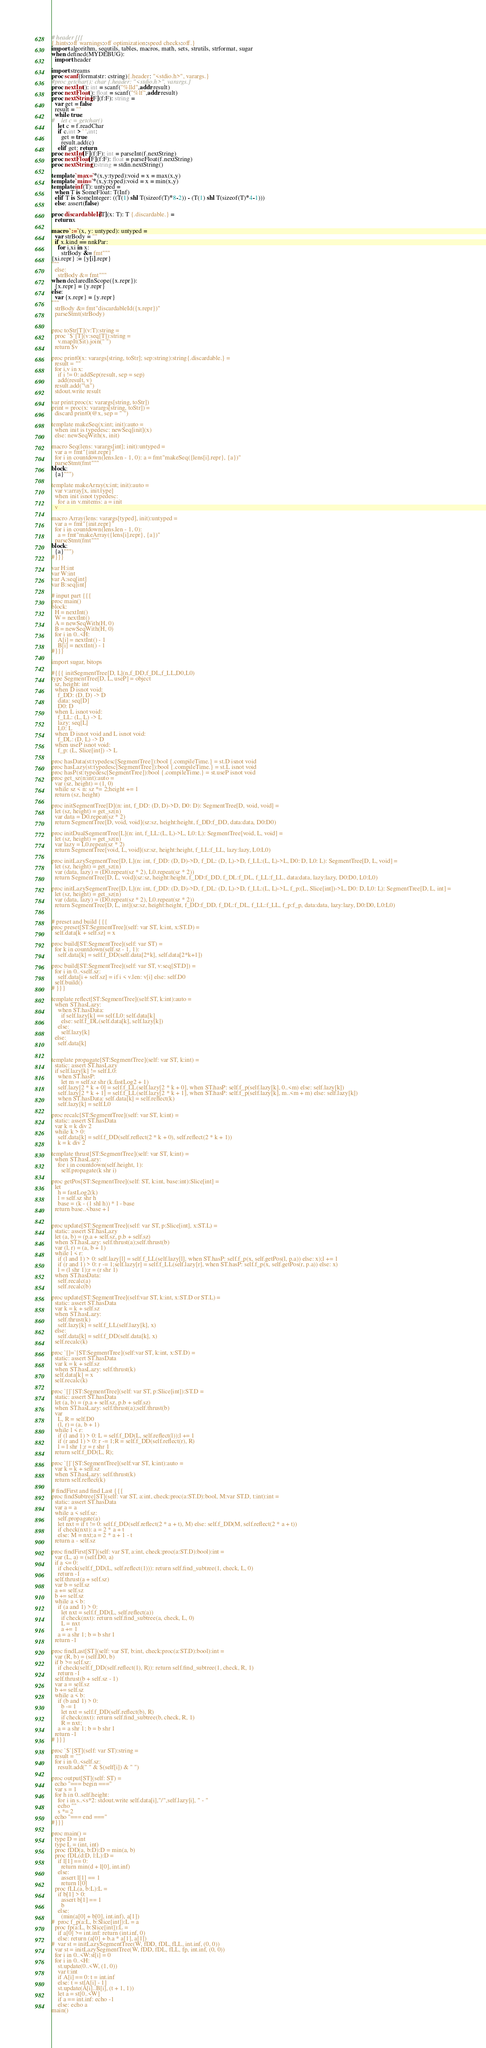<code> <loc_0><loc_0><loc_500><loc_500><_Nim_># header {{{
{.hints:off warnings:off optimization:speed checks:off.}
import algorithm, sequtils, tables, macros, math, sets, strutils, strformat, sugar
when defined(MYDEBUG):
  import header

import streams
proc scanf(formatstr: cstring){.header: "<stdio.h>", varargs.}
#proc getchar(): char {.header: "<stdio.h>", varargs.}
proc nextInt(): int = scanf("%lld",addr result)
proc nextFloat(): float = scanf("%lf",addr result)
proc nextString[F](f:F): string =
  var get = false
  result = ""
  while true:
#    let c = getchar()
    let c = f.readChar
    if c.int > ' '.int:
      get = true
      result.add(c)
    elif get: return
proc nextInt[F](f:F): int = parseInt(f.nextString)
proc nextFloat[F](f:F): float = parseFloat(f.nextString)
proc nextString():string = stdin.nextString()

template `max=`*(x,y:typed):void = x = max(x,y)
template `min=`*(x,y:typed):void = x = min(x,y)
template inf(T): untyped = 
  when T is SomeFloat: T(Inf)
  elif T is SomeInteger: ((T(1) shl T(sizeof(T)*8-2)) - (T(1) shl T(sizeof(T)*4-1)))
  else: assert(false)

proc discardableId[T](x: T): T {.discardable.} =
  return x

macro `:=`(x, y: untyped): untyped =
  var strBody = ""
  if x.kind == nnkPar:
    for i,xi in x:
      strBody &= fmt"""
{xi.repr} := {y[i].repr}
"""
  else:
    strBody &= fmt"""
when declaredInScope({x.repr}):
  {x.repr} = {y.repr}
else:
  var {x.repr} = {y.repr}
"""
  strBody &= fmt"discardableId({x.repr})"
  parseStmt(strBody)


proc toStr[T](v:T):string =
  proc `$`[T](v:seq[T]):string =
    v.mapIt($it).join(" ")
  return $v

proc print0(x: varargs[string, toStr]; sep:string):string{.discardable.} =
  result = ""
  for i,v in x:
    if i != 0: addSep(result, sep = sep)
    add(result, v)
  result.add("\n")
  stdout.write result

var print:proc(x: varargs[string, toStr])
print = proc(x: varargs[string, toStr]) =
  discard print0(@x, sep = " ")

template makeSeq(x:int; init):auto =
  when init is typedesc: newSeq[init](x)
  else: newSeqWith(x, init)

macro Seq(lens: varargs[int]; init):untyped =
  var a = fmt"{init.repr}"
  for i in countdown(lens.len - 1, 0): a = fmt"makeSeq({lens[i].repr}, {a})"
  parseStmt(fmt"""
block:
  {a}""")

template makeArray(x:int; init):auto =
  var v:array[x, init.type]
  when init isnot typedesc:
    for a in v.mitems: a = init
  v

macro Array(lens: varargs[typed], init):untyped =
  var a = fmt"{init.repr}"
  for i in countdown(lens.len - 1, 0):
    a = fmt"makeArray({lens[i].repr}, {a})"
  parseStmt(fmt"""
block:
  {a}""")
#}}}

var H:int
var W:int
var A:seq[int]
var B:seq[int]

# input part {{{
proc main()
block:
  H = nextInt()
  W = nextInt()
  A = newSeqWith(H, 0)
  B = newSeqWith(H, 0)
  for i in 0..<H:
    A[i] = nextInt() - 1
    B[i] = nextInt() - 1
#}}}

import sugar, bitops

#{{{ initSegmentTree[D, L](n,f_DD,f_DL,f_LL,D0,L0)
type SegmentTree[D, L, useP] = object
  sz, height: int
  when D isnot void:
    f_DD: (D, D) -> D
    data: seq[D]
    D0: D
  when L isnot void:
    f_LL: (L, L) -> L
    lazy: seq[L]
    L0: L
  when D isnot void and L isnot void:
    f_DL: (D, L) -> D
  when useP isnot void:
    f_p: (L, Slice[int]) -> L

proc hasData(st:typedesc[SegmentTree]):bool {.compileTime.} = st.D isnot void
proc hasLazy(st:typedesc[SegmentTree]):bool {.compileTime.} = st.L isnot void
proc hasP(st:typedesc[SegmentTree]):bool {.compileTime.} = st.useP isnot void
proc get_sz(n:int):auto =
  var (sz, height) = (1, 0)
  while sz < n: sz *= 2;height += 1
  return (sz, height)

proc initSegmentTree[D](n: int, f_DD: (D, D)->D, D0: D): SegmentTree[D, void, void] =
  let (sz, height) = get_sz(n)
  var data = D0.repeat(sz * 2)
  return SegmentTree[D, void, void](sz:sz, height:height, f_DD:f_DD, data:data, D0:D0)

proc initDualSegmentTree[L](n: int, f_LL:(L, L)->L, L0: L): SegmentTree[void, L, void] =
  let (sz, height) = get_sz(n)
  var lazy = L0.repeat(sz * 2)
  return SegmentTree[void, L, void](sz:sz, height:height, f_LL:f_LL, lazy:lazy, L0:L0)

proc initLazySegmentTree[D, L](n: int, f_DD: (D, D)->D, f_DL: (D, L)->D, f_LL:(L, L)->L, D0: D, L0: L): SegmentTree[D, L, void] =
  let (sz, height) = get_sz(n)
  var (data, lazy) = (D0.repeat(sz * 2), L0.repeat(sz * 2))
  return SegmentTree[D, L, void](sz:sz, height:height, f_DD:f_DD, f_DL:f_DL, f_LL:f_LL, data:data, lazy:lazy, D0:D0, L0:L0)

proc initLazySegmentTree[D, L](n: int, f_DD: (D, D)->D, f_DL: (D, L)->D, f_LL:(L, L)->L, f_p:(L, Slice[int])->L, D0: D, L0: L): SegmentTree[D, L, int] =
  let (sz, height) = get_sz(n)
  var (data, lazy) = (D0.repeat(sz * 2), L0.repeat(sz * 2))
  return SegmentTree[D, L, int](sz:sz, height:height, f_DD:f_DD, f_DL:f_DL, f_LL:f_LL, f_p:f_p, data:data, lazy:lazy, D0:D0, L0:L0)


# preset and build {{{
proc preset[ST:SegmentTree](self: var ST, k:int, x:ST.D) =
  self.data[k + self.sz] = x

proc build[ST:SegmentTree](self: var ST) =
  for k in countdown(self.sz - 1, 1):
    self.data[k] = self.f_DD(self.data[2*k], self.data[2*k+1])

proc build[ST:SegmentTree](self: var ST, v:seq[ST.D]) =
  for i in 0..<self.sz:
    self.data[i + self.sz] = if i < v.len: v[i] else: self.D0
  self.build()
# }}}

template reflect[ST:SegmentTree](self:ST, k:int):auto =
  when ST.hasLazy:
    when ST.hasData:
      if self.lazy[k] == self.L0: self.data[k]
      else: self.f_DL(self.data[k], self.lazy[k])
    else:
      self.lazy[k]
  else:
    self.data[k]


template propagate[ST:SegmentTree](self: var ST, k:int) =
  static: assert ST.hasLazy
  if self.lazy[k] != self.L0:
    when ST.hasP:
      let m = self.sz shr (k.fastLog2 + 1)
    self.lazy[2 * k + 0] = self.f_LL(self.lazy[2 * k + 0], when ST.hasP: self.f_p(self.lazy[k], 0..<m) else: self.lazy[k])
    self.lazy[2 * k + 1] = self.f_LL(self.lazy[2 * k + 1], when ST.hasP: self.f_p(self.lazy[k], m..<m + m) else: self.lazy[k])
    when ST.hasData: self.data[k] = self.reflect(k)
    self.lazy[k] = self.L0

proc recalc[ST:SegmentTree](self: var ST, k:int) =
  static: assert ST.hasData
  var k = k div 2
  while k > 0:
    self.data[k] = self.f_DD(self.reflect(2 * k + 0), self.reflect(2 * k + 1))
    k = k div 2

template thrust[ST:SegmentTree](self: var ST, k:int) =
  when ST.hasLazy:
    for i in countdown(self.height, 1):
      self.propagate(k shr i)

proc getPos[ST:SegmentTree](self: ST, k:int, base:int):Slice[int] =
  let
    h = fastLog2(k)
    l = self.sz shr h
    base = (k - (1 shl h)) * l - base
  return base..<base + l


proc update[ST:SegmentTree](self: var ST, p:Slice[int], x:ST.L) =
  static: assert ST.hasLazy
  let (a, b) = (p.a + self.sz, p.b + self.sz)
  when ST.hasLazy: self.thrust(a);self.thrust(b)
  var (l, r) = (a, b + 1)
  while l < r:
    if (l and 1) > 0: self.lazy[l] = self.f_LL(self.lazy[l], when ST.hasP: self.f_p(x, self.getPos(l, p.a)) else: x);l += 1
    if (r and 1) > 0: r -= 1;self.lazy[r] = self.f_LL(self.lazy[r], when ST.hasP: self.f_p(x, self.getPos(r, p.a)) else: x)
    l = (l shr 1);r = (r shr 1)
  when ST.hasData:
    self.recalc(a)
    self.recalc(b)

proc update[ST:SegmentTree](self:var ST, k:int, x:ST.D or ST.L) =
  static: assert ST.hasData
  var k = k + self.sz
  when ST.hasLazy:
    self.thrust(k)
    self.lazy[k] = self.f_LL(self.lazy[k], x)
  else:
    self.data[k] = self.f_DD(self.data[k], x)
  self.recalc(k)

proc `[]=`[ST:SegmentTree](self:var ST, k:int, x:ST.D) =
  static: assert ST.hasData
  var k = k + self.sz
  when ST.hasLazy: self.thrust(k)
  self.data[k] = x
  self.recalc(k)

proc `[]`[ST:SegmentTree](self: var ST, p:Slice[int]):ST.D =
  static: assert ST.hasData
  let (a, b) = (p.a + self.sz, p.b + self.sz)
  when ST.hasLazy: self.thrust(a);self.thrust(b)
  var
    L, R = self.D0
    (l, r) = (a, b + 1)
  while l < r:
    if (l and 1) > 0: L = self.f_DD(L, self.reflect(l));l += 1
    if (r and 1) > 0: r -= 1;R = self.f_DD(self.reflect(r), R)
    l = l shr 1;r = r shr 1
  return self.f_DD(L, R);

proc `[]`[ST:SegmentTree](self:var ST, k:int):auto =
  var k = k + self.sz
  when ST.hasLazy: self.thrust(k)
  return self.reflect(k)

# findFirst and find Last {{{
proc findSubtree[ST](self: var ST, a:int, check:proc(a:ST.D):bool, M:var ST.D, t:int):int =
  static: assert ST.hasData
  var a = a
  while a < self.sz:
    self.propagate(a)
    let nxt = if t != 0: self.f_DD(self.reflect(2 * a + t), M) else: self.f_DD(M, self.reflect(2 * a + t))
    if check(nxt): a = 2 * a + t
    else: M = nxt;a = 2 * a + 1 - t
  return a - self.sz

proc findFirst[ST](self: var ST, a:int, check:proc(a:ST.D):bool):int =
  var (L, a) = (self.D0, a)
  if a <= 0:
    if check(self.f_DD(L, self.reflect(1))): return self.find_subtree(1, check, L, 0)
    return -1
  self.thrust(a + self.sz)
  var b = self.sz
  a += self.sz
  b += self.sz
  while a < b:
    if (a and 1) > 0:
      let nxt = self.f_DD(L, self.reflect(a))
      if check(nxt): return self.find_subtree(a, check, L, 0)
      L = nxt
      a += 1
    a = a shr 1; b = b shr 1
  return -1

proc findLast[ST](self: var ST, b:int, check:proc(a:ST.D):bool):int =
  var (R, b) = (self.D0, b)
  if b >= self.sz:
    if check(self.f_DD(self.reflect(1), R)): return self.find_subtree(1, check, R, 1)
    return -1
  self.thrust(b + self.sz - 1)
  var a = self.sz
  b += self.sz
  while a < b:
    if (b and 1) > 0:
      b -= 1
      let nxt = self.f_DD(self.reflect(b), R)
      if check(nxt): return self.find_subtree(b, check, R, 1)
      R = nxt;
    a = a shr 1; b = b shr 1
  return -1
# }}}

proc `$`[ST](self: var ST):string =
  result = ""
  for i in 0..<self.sz:
    result.add(" " & $(self[i]) & " ")

proc output[ST](self: ST) =
  echo "=== begin ==="
  var s = 1
  for h in 0..self.height:
    for i in s..<s*2: stdout.write self.data[i],"/",self.lazy[i], " - "
    echo ""
    s *= 2
  echo "=== end ==="
#}}}

proc main() =
  type D = int
  type L = (int, int)
  proc fDD(a, b:D):D = min(a, b)
  proc fDL(d:D, l:L):D =
    if l[1] == 0:
      return min(d + l[0], int.inf)
    else:
      assert l[1] == 1
      return l[0]
  proc fLL(a, b:L):L =
    if b[1] > 0:
      assert b[1] == 1
      b
    else:
      (min(a[0] + b[0], int.inf), a[1])
#  proc f_p(a:L, b:Slice[int]):L = a
  proc fp(a:L, b:Slice[int]):L =
    if a[0] >= int.inf: return (int.inf, 0)
    else: return (a[0] + b.a * a[1], a[1])
#  var st = initLazySegmentTree(W, fDD, fDL, fLL, int.inf, (0, 0))
  var st = initLazySegmentTree(W, fDD, fDL, fLL, fp, int.inf, (0, 0))
  for i in 0..<W:st[i] = 0
  for i in 0..<H:
    st.update(0..<W, (1, 0))
    var t:int
    if A[i] == 0: t = int.inf
    else: t = st[A[i] - 1]
    st.update(A[i]..B[i], (t + 1, 1))
    let a = st[0..<W]
    if a == int.inf: echo -1
    else: echo a
main()

</code> 